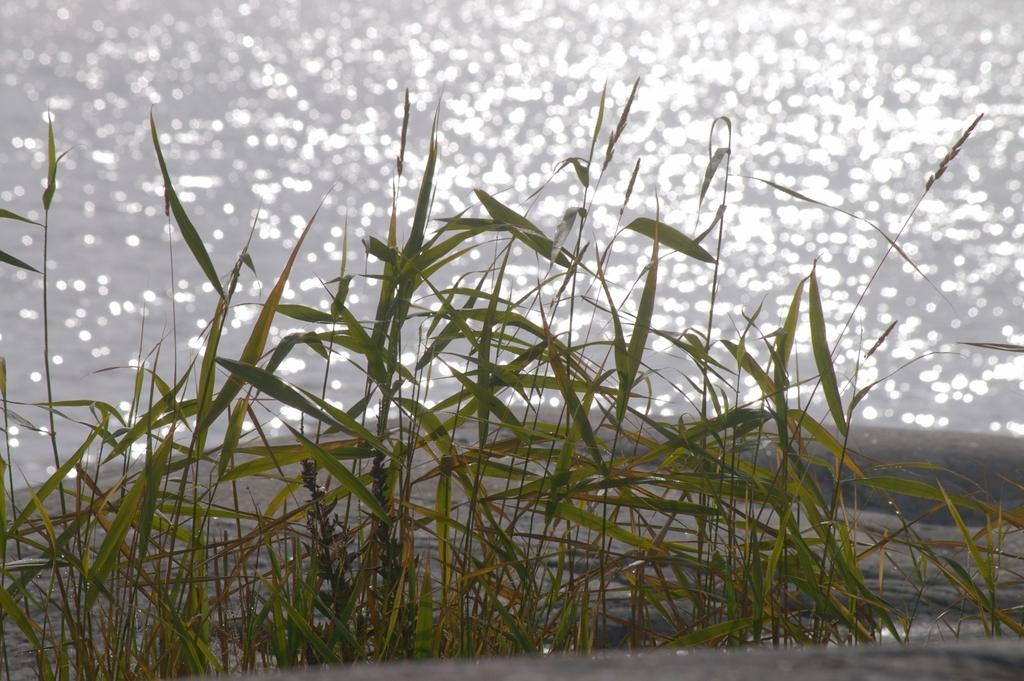Could you give a brief overview of what you see in this image? These are the and this is water. 